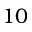Convert formula to latex. <formula><loc_0><loc_0><loc_500><loc_500>1 0</formula> 